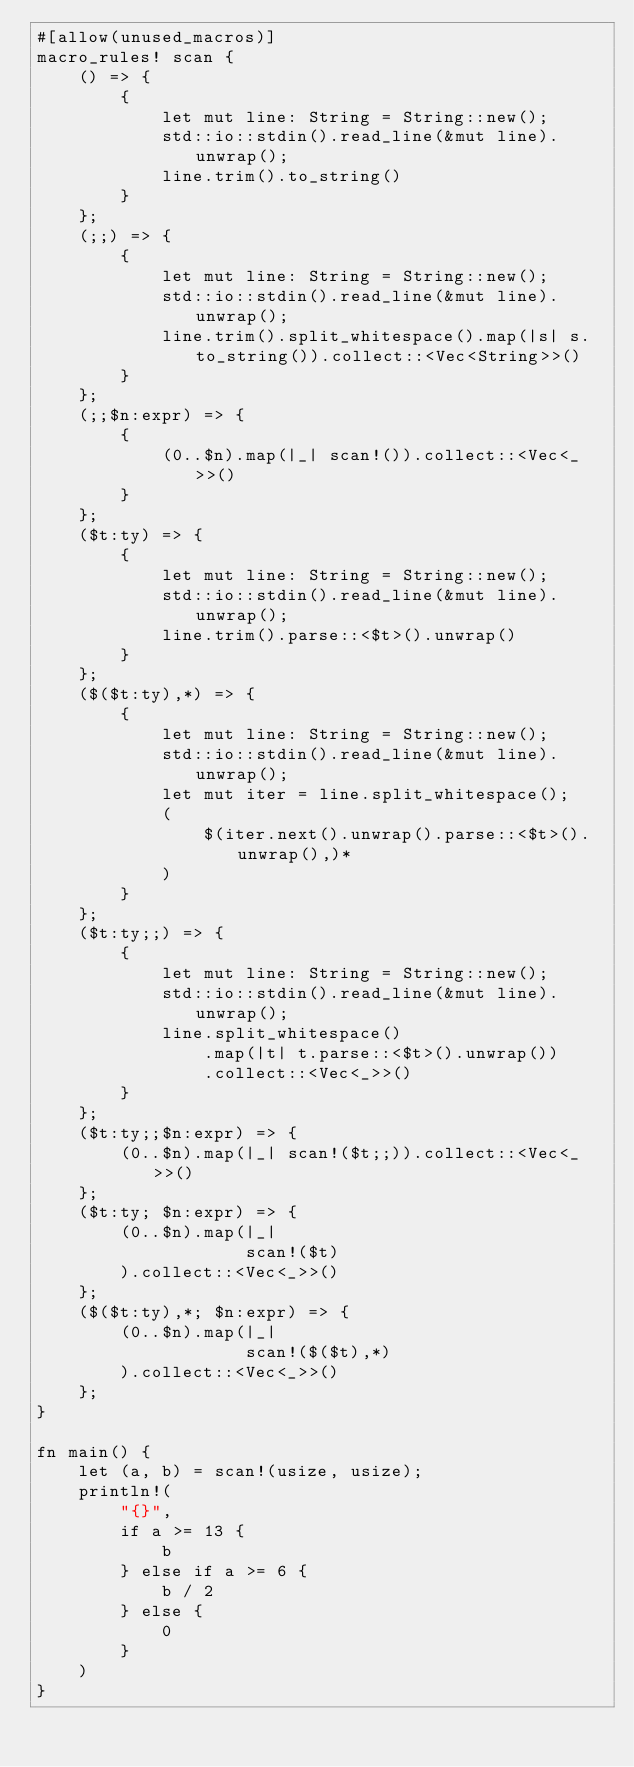Convert code to text. <code><loc_0><loc_0><loc_500><loc_500><_Rust_>#[allow(unused_macros)]
macro_rules! scan {
    () => {
        {
            let mut line: String = String::new();
            std::io::stdin().read_line(&mut line).unwrap();
            line.trim().to_string()
        }
    };
    (;;) => {
        {
            let mut line: String = String::new();
            std::io::stdin().read_line(&mut line).unwrap();
            line.trim().split_whitespace().map(|s| s.to_string()).collect::<Vec<String>>()
        }
    };
    (;;$n:expr) => {
        {
            (0..$n).map(|_| scan!()).collect::<Vec<_>>()
        }
    };
    ($t:ty) => {
        {
            let mut line: String = String::new();
            std::io::stdin().read_line(&mut line).unwrap();
            line.trim().parse::<$t>().unwrap()
        }
    };
    ($($t:ty),*) => {
        {
            let mut line: String = String::new();
            std::io::stdin().read_line(&mut line).unwrap();
            let mut iter = line.split_whitespace();
            (
                $(iter.next().unwrap().parse::<$t>().unwrap(),)*
            )
        }
    };
    ($t:ty;;) => {
        {
            let mut line: String = String::new();
            std::io::stdin().read_line(&mut line).unwrap();
            line.split_whitespace()
                .map(|t| t.parse::<$t>().unwrap())
                .collect::<Vec<_>>()
        }
    };
    ($t:ty;;$n:expr) => {
        (0..$n).map(|_| scan!($t;;)).collect::<Vec<_>>()
    };
    ($t:ty; $n:expr) => {
        (0..$n).map(|_|
                    scan!($t)
        ).collect::<Vec<_>>()
    };
    ($($t:ty),*; $n:expr) => {
        (0..$n).map(|_|
                    scan!($($t),*)
        ).collect::<Vec<_>>()
    };
}

fn main() {
    let (a, b) = scan!(usize, usize);
    println!(
        "{}",
        if a >= 13 {
            b
        } else if a >= 6 {
            b / 2
        } else {
            0
        }
    )
}
</code> 